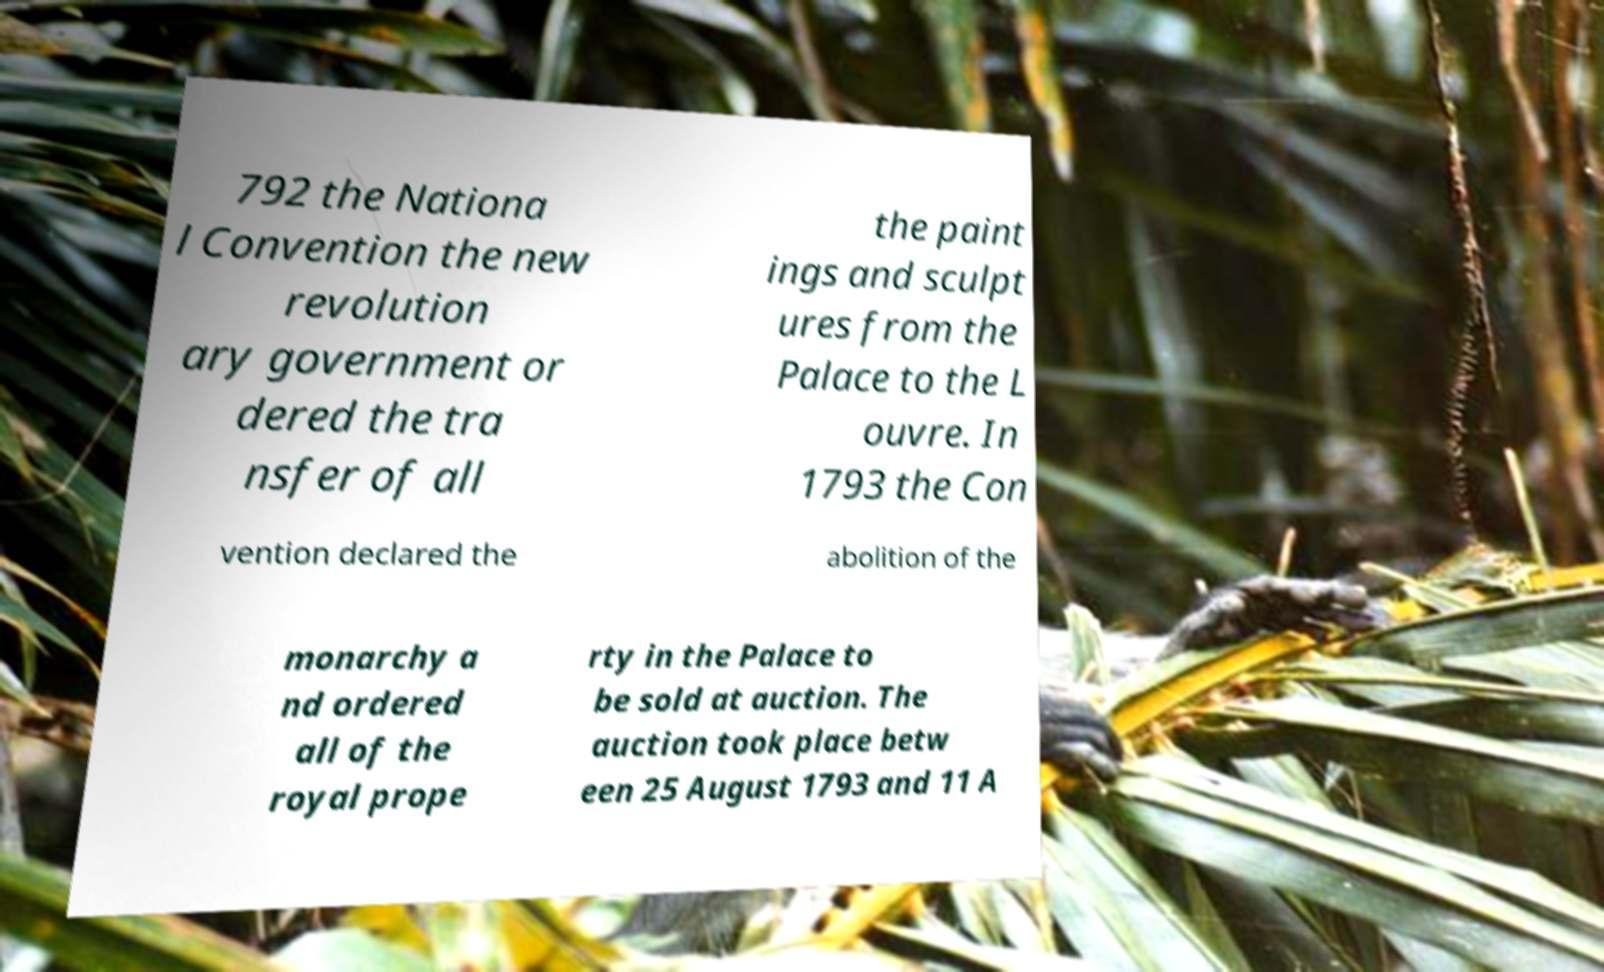Please identify and transcribe the text found in this image. 792 the Nationa l Convention the new revolution ary government or dered the tra nsfer of all the paint ings and sculpt ures from the Palace to the L ouvre. In 1793 the Con vention declared the abolition of the monarchy a nd ordered all of the royal prope rty in the Palace to be sold at auction. The auction took place betw een 25 August 1793 and 11 A 